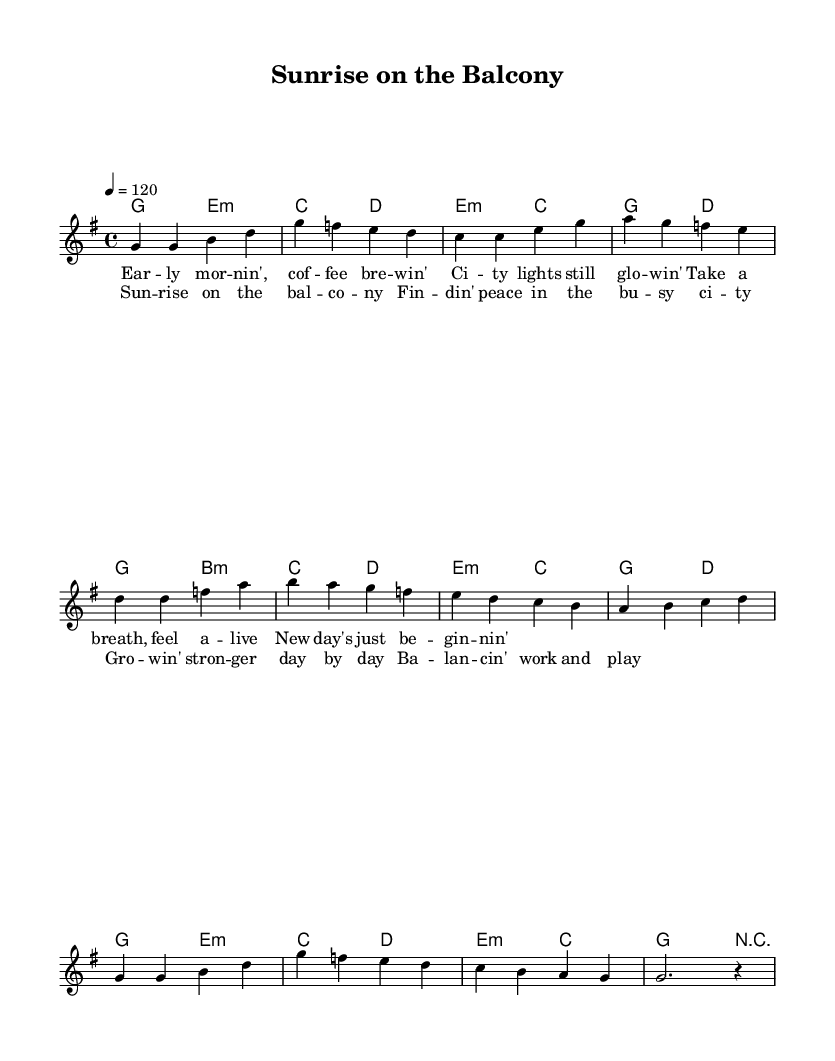What is the key signature of this music? The key signature is indicated at the beginning of the staff. In this case, it shows one sharp, which corresponds to the G major key.
Answer: G major What is the time signature of this music? The time signature is found at the beginning of the staff, indicated as 4/4, meaning there are four beats per measure and the quarter note gets one beat.
Answer: 4/4 What is the tempo of the piece? The tempo is indicated at the beginning with the symbol and number, where it states "4 = 120." This means there are 120 beats per minute.
Answer: 120 How many measures are in the melody? To find the number of measures, one can count the notation lines between the bar lines in the melody section. There are a total of 8 measures.
Answer: 8 What does the chorus of the song emphasize about urban life? The chorus highlights finding peace and balancing work and play in a busy city, which relates to the theme of work-life balance.
Answer: Finding peace in the busy city In the verse, what imagery is used to evoke a sense of morning? The verse uses imagery like "coffee brewin'" and "city lights still glowin'" to create a scene of a fresh start and awakening in the morning.
Answer: Coffee brewin' What is the structure of this song? The structure of the song consists of verses followed by a repeating chorus, which is a common structure in country music, emphasizing the themes of personal growth and balance.
Answer: Verse-Chorus 